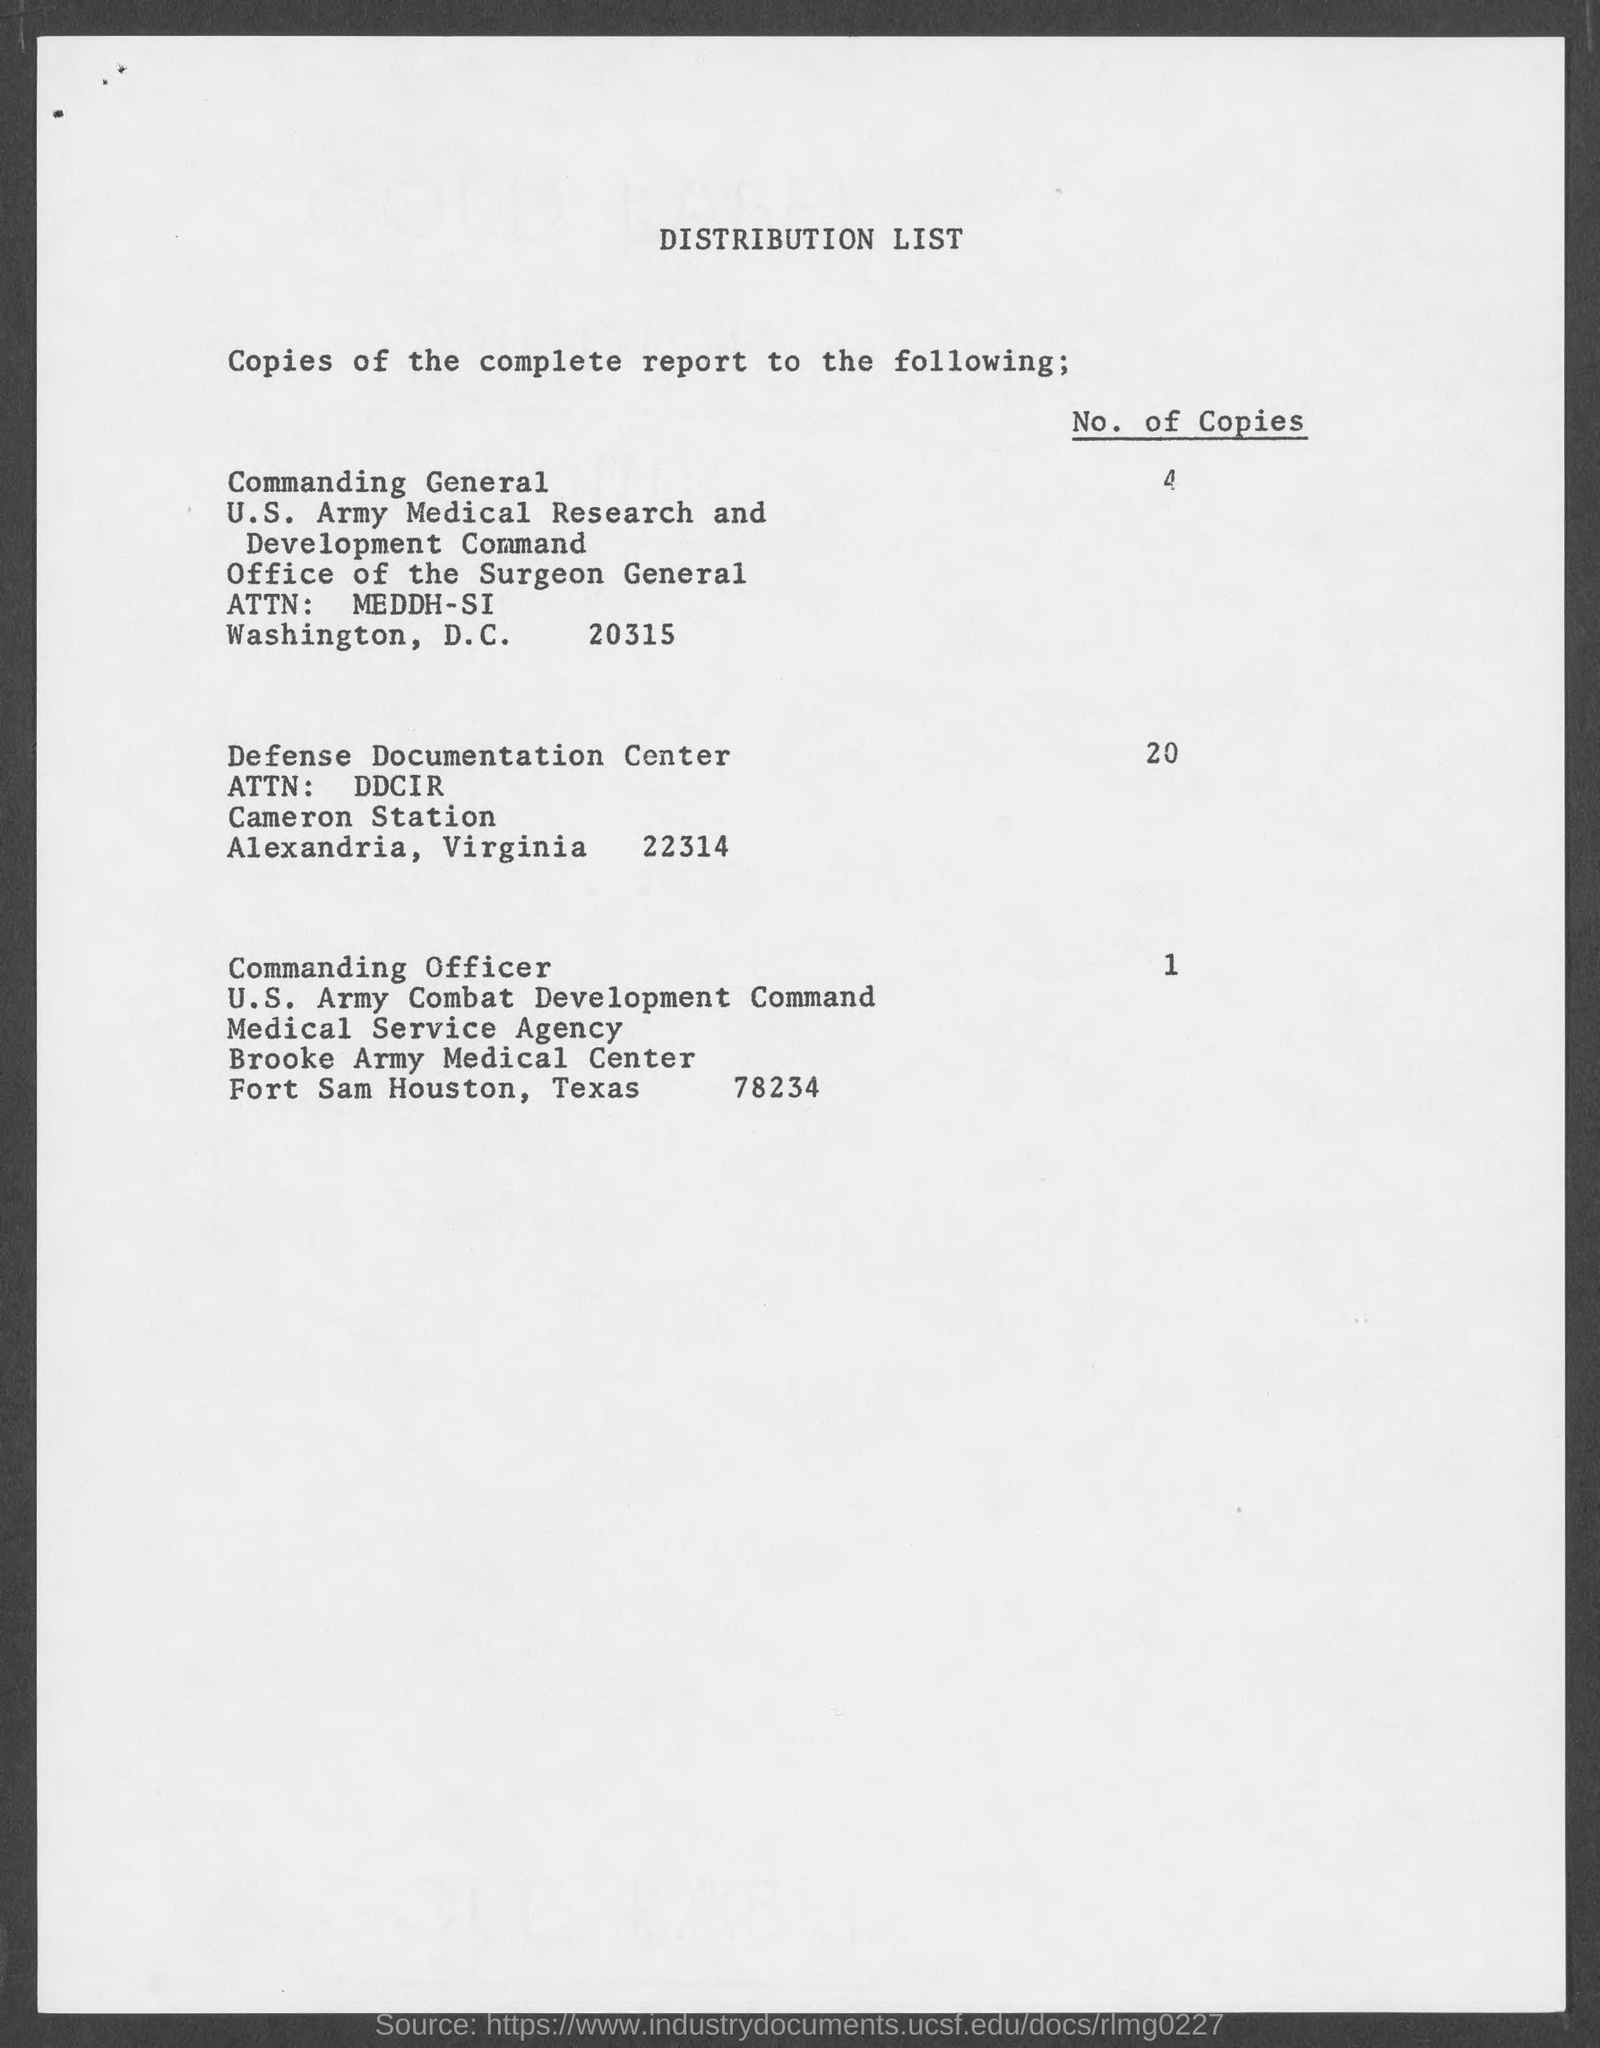Do any recipients listed share the same city for their addresses? No, all the recipients listed have different city addresses for the distribution of the report. 